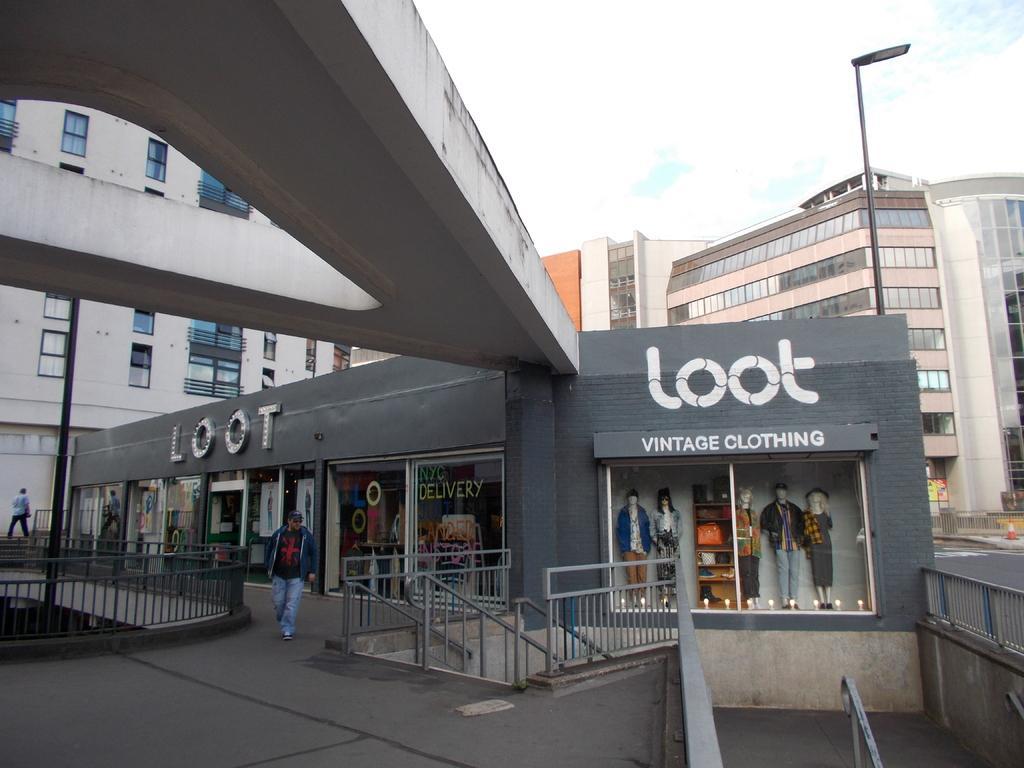Describe this image in one or two sentences. In this image in the center there are some buildings poles and some stores, and in the stores there are some manikins and also there is railing. At the bottom there is a walkway, and at the top of the image there is sky. 